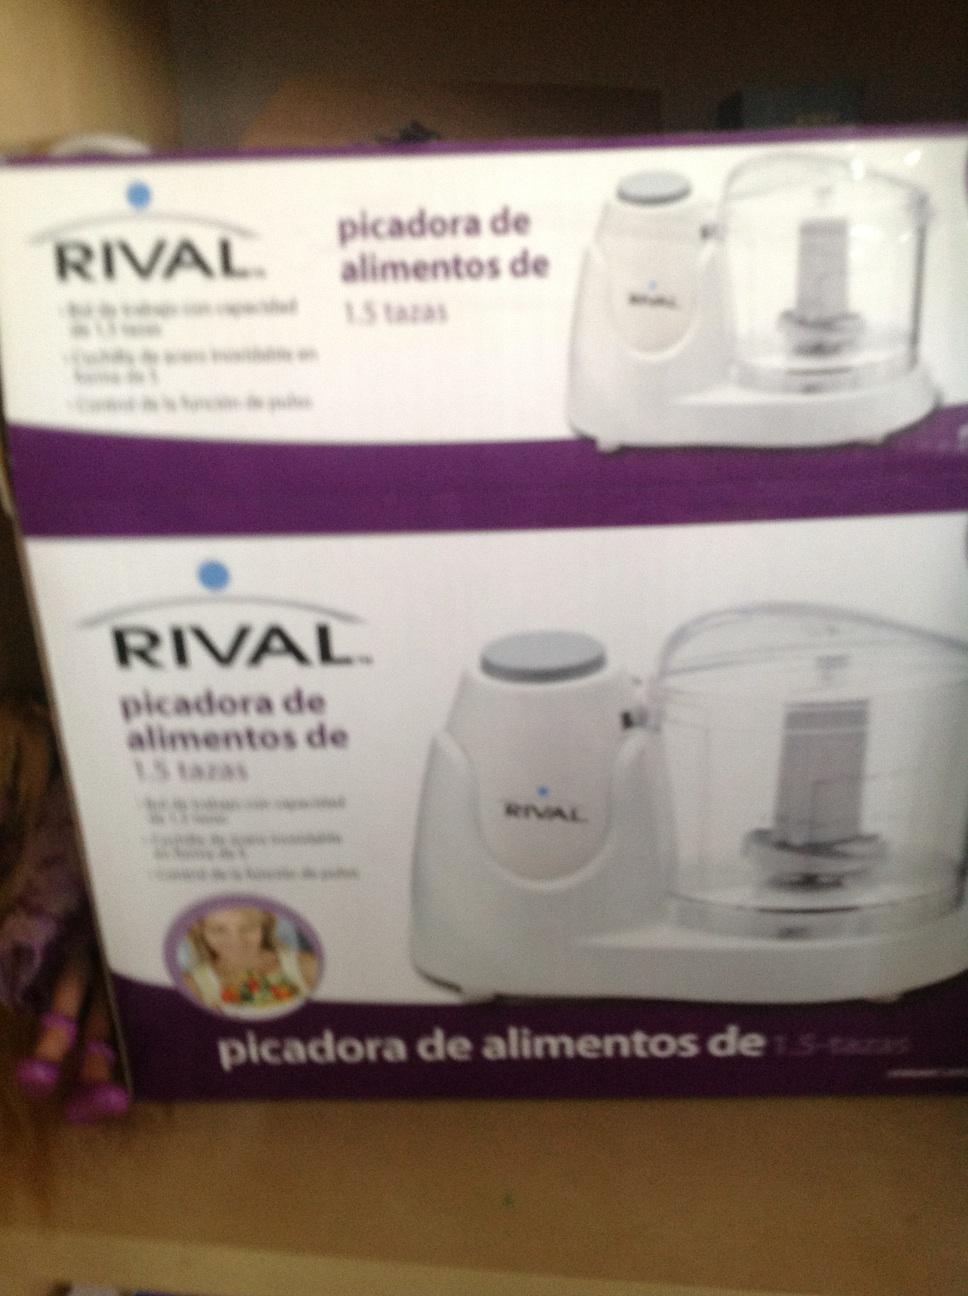How might this product be used in a kitchen? This RIVAL food chopper would be used to quickly and efficiently chop small amounts of food. You could use it for vegetables, nuts, or herbs. For instance, it could chop onions or garlic for a recipe, create a quick salsa, or even chop nuts for baking. 